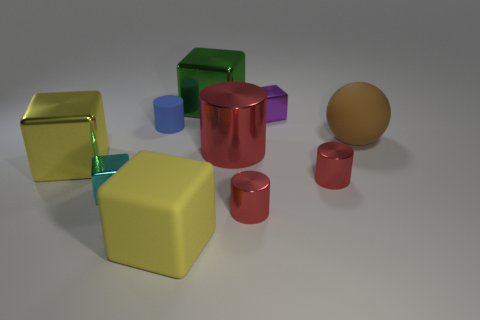What is the size of the yellow cube that is made of the same material as the tiny blue cylinder?
Ensure brevity in your answer.  Large. Is there anything else that is the same color as the ball?
Your answer should be very brief. No. What is the color of the metallic cube that is behind the purple object?
Your answer should be compact. Green. Is there a large block that is left of the block in front of the red thing that is in front of the cyan metal thing?
Offer a very short reply. Yes. Are there more large green blocks that are in front of the big green metal cube than big red shiny things?
Offer a terse response. No. There is a small metal thing behind the big red cylinder; is its shape the same as the green object?
Ensure brevity in your answer.  Yes. Is there anything else that has the same material as the large cylinder?
Give a very brief answer. Yes. How many things are either metallic blocks or big metal objects to the right of the large yellow matte object?
Your answer should be very brief. 5. There is a cube that is right of the cyan metal object and in front of the big brown rubber sphere; what size is it?
Your response must be concise. Large. Is the number of tiny metallic objects that are in front of the big brown thing greater than the number of tiny cyan metal cubes on the right side of the blue cylinder?
Provide a short and direct response. Yes. 